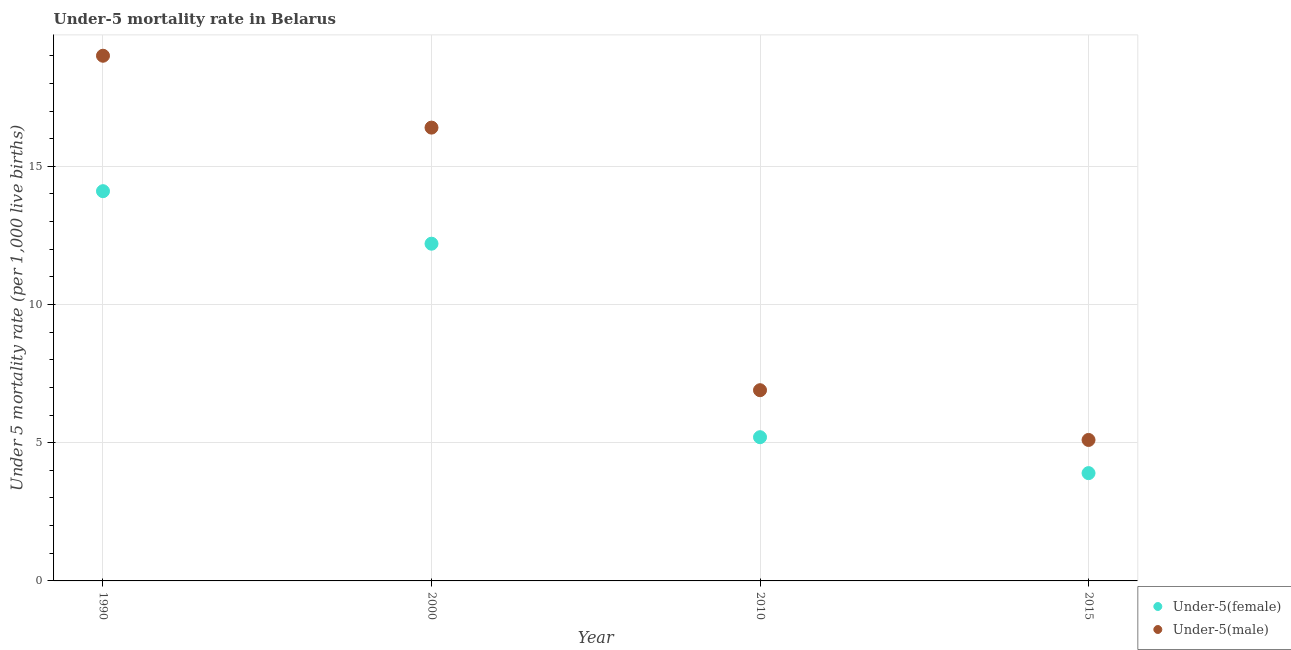How many different coloured dotlines are there?
Your answer should be compact. 2. In which year was the under-5 female mortality rate maximum?
Provide a short and direct response. 1990. In which year was the under-5 female mortality rate minimum?
Give a very brief answer. 2015. What is the total under-5 male mortality rate in the graph?
Keep it short and to the point. 47.4. What is the difference between the under-5 male mortality rate in 2000 and that in 2015?
Offer a terse response. 11.3. What is the difference between the under-5 female mortality rate in 1990 and the under-5 male mortality rate in 2000?
Offer a terse response. -2.3. What is the average under-5 female mortality rate per year?
Provide a succinct answer. 8.85. In the year 2010, what is the difference between the under-5 female mortality rate and under-5 male mortality rate?
Your response must be concise. -1.7. What is the ratio of the under-5 female mortality rate in 1990 to that in 2015?
Make the answer very short. 3.62. Is the under-5 male mortality rate in 2000 less than that in 2010?
Give a very brief answer. No. Is the difference between the under-5 male mortality rate in 2010 and 2015 greater than the difference between the under-5 female mortality rate in 2010 and 2015?
Ensure brevity in your answer.  Yes. What is the difference between the highest and the second highest under-5 female mortality rate?
Give a very brief answer. 1.9. In how many years, is the under-5 male mortality rate greater than the average under-5 male mortality rate taken over all years?
Make the answer very short. 2. Is the under-5 female mortality rate strictly greater than the under-5 male mortality rate over the years?
Make the answer very short. No. Is the under-5 male mortality rate strictly less than the under-5 female mortality rate over the years?
Make the answer very short. No. How many years are there in the graph?
Give a very brief answer. 4. What is the difference between two consecutive major ticks on the Y-axis?
Ensure brevity in your answer.  5. Are the values on the major ticks of Y-axis written in scientific E-notation?
Keep it short and to the point. No. Where does the legend appear in the graph?
Offer a terse response. Bottom right. How many legend labels are there?
Your response must be concise. 2. What is the title of the graph?
Your answer should be compact. Under-5 mortality rate in Belarus. What is the label or title of the X-axis?
Provide a short and direct response. Year. What is the label or title of the Y-axis?
Ensure brevity in your answer.  Under 5 mortality rate (per 1,0 live births). What is the Under 5 mortality rate (per 1,000 live births) of Under-5(female) in 2010?
Your answer should be compact. 5.2. Across all years, what is the minimum Under 5 mortality rate (per 1,000 live births) of Under-5(female)?
Your answer should be compact. 3.9. Across all years, what is the minimum Under 5 mortality rate (per 1,000 live births) in Under-5(male)?
Your answer should be very brief. 5.1. What is the total Under 5 mortality rate (per 1,000 live births) of Under-5(female) in the graph?
Your answer should be compact. 35.4. What is the total Under 5 mortality rate (per 1,000 live births) of Under-5(male) in the graph?
Your answer should be compact. 47.4. What is the difference between the Under 5 mortality rate (per 1,000 live births) of Under-5(female) in 1990 and that in 2000?
Offer a very short reply. 1.9. What is the difference between the Under 5 mortality rate (per 1,000 live births) of Under-5(male) in 1990 and that in 2000?
Keep it short and to the point. 2.6. What is the difference between the Under 5 mortality rate (per 1,000 live births) of Under-5(male) in 1990 and that in 2015?
Your answer should be very brief. 13.9. What is the difference between the Under 5 mortality rate (per 1,000 live births) of Under-5(female) in 2010 and that in 2015?
Your response must be concise. 1.3. What is the difference between the Under 5 mortality rate (per 1,000 live births) in Under-5(male) in 2010 and that in 2015?
Give a very brief answer. 1.8. What is the difference between the Under 5 mortality rate (per 1,000 live births) in Under-5(female) in 1990 and the Under 5 mortality rate (per 1,000 live births) in Under-5(male) in 2000?
Provide a succinct answer. -2.3. What is the difference between the Under 5 mortality rate (per 1,000 live births) in Under-5(female) in 2000 and the Under 5 mortality rate (per 1,000 live births) in Under-5(male) in 2015?
Give a very brief answer. 7.1. What is the difference between the Under 5 mortality rate (per 1,000 live births) of Under-5(female) in 2010 and the Under 5 mortality rate (per 1,000 live births) of Under-5(male) in 2015?
Provide a short and direct response. 0.1. What is the average Under 5 mortality rate (per 1,000 live births) in Under-5(female) per year?
Offer a terse response. 8.85. What is the average Under 5 mortality rate (per 1,000 live births) of Under-5(male) per year?
Offer a very short reply. 11.85. In the year 2000, what is the difference between the Under 5 mortality rate (per 1,000 live births) of Under-5(female) and Under 5 mortality rate (per 1,000 live births) of Under-5(male)?
Your answer should be compact. -4.2. What is the ratio of the Under 5 mortality rate (per 1,000 live births) of Under-5(female) in 1990 to that in 2000?
Provide a succinct answer. 1.16. What is the ratio of the Under 5 mortality rate (per 1,000 live births) of Under-5(male) in 1990 to that in 2000?
Provide a succinct answer. 1.16. What is the ratio of the Under 5 mortality rate (per 1,000 live births) of Under-5(female) in 1990 to that in 2010?
Keep it short and to the point. 2.71. What is the ratio of the Under 5 mortality rate (per 1,000 live births) of Under-5(male) in 1990 to that in 2010?
Make the answer very short. 2.75. What is the ratio of the Under 5 mortality rate (per 1,000 live births) of Under-5(female) in 1990 to that in 2015?
Provide a succinct answer. 3.62. What is the ratio of the Under 5 mortality rate (per 1,000 live births) of Under-5(male) in 1990 to that in 2015?
Provide a succinct answer. 3.73. What is the ratio of the Under 5 mortality rate (per 1,000 live births) of Under-5(female) in 2000 to that in 2010?
Your answer should be very brief. 2.35. What is the ratio of the Under 5 mortality rate (per 1,000 live births) of Under-5(male) in 2000 to that in 2010?
Keep it short and to the point. 2.38. What is the ratio of the Under 5 mortality rate (per 1,000 live births) in Under-5(female) in 2000 to that in 2015?
Keep it short and to the point. 3.13. What is the ratio of the Under 5 mortality rate (per 1,000 live births) of Under-5(male) in 2000 to that in 2015?
Your answer should be compact. 3.22. What is the ratio of the Under 5 mortality rate (per 1,000 live births) in Under-5(male) in 2010 to that in 2015?
Offer a very short reply. 1.35. What is the difference between the highest and the second highest Under 5 mortality rate (per 1,000 live births) of Under-5(female)?
Offer a terse response. 1.9. 